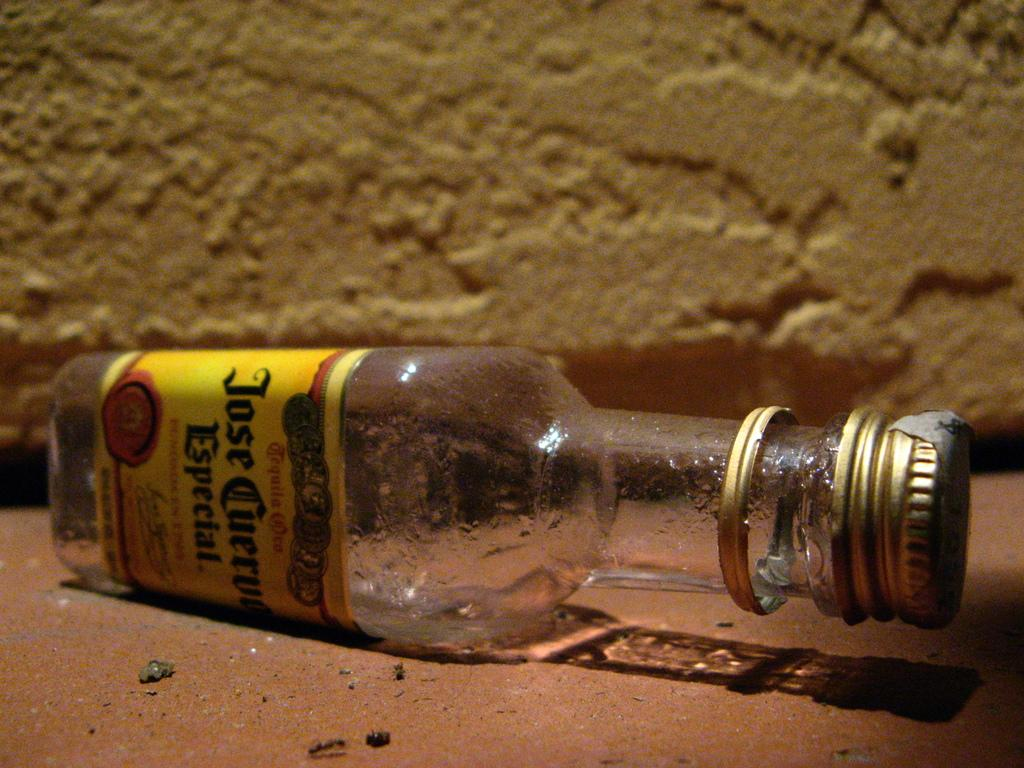<image>
Create a compact narrative representing the image presented. an empty bottle of jose cuervo especial on the ground on it's side 